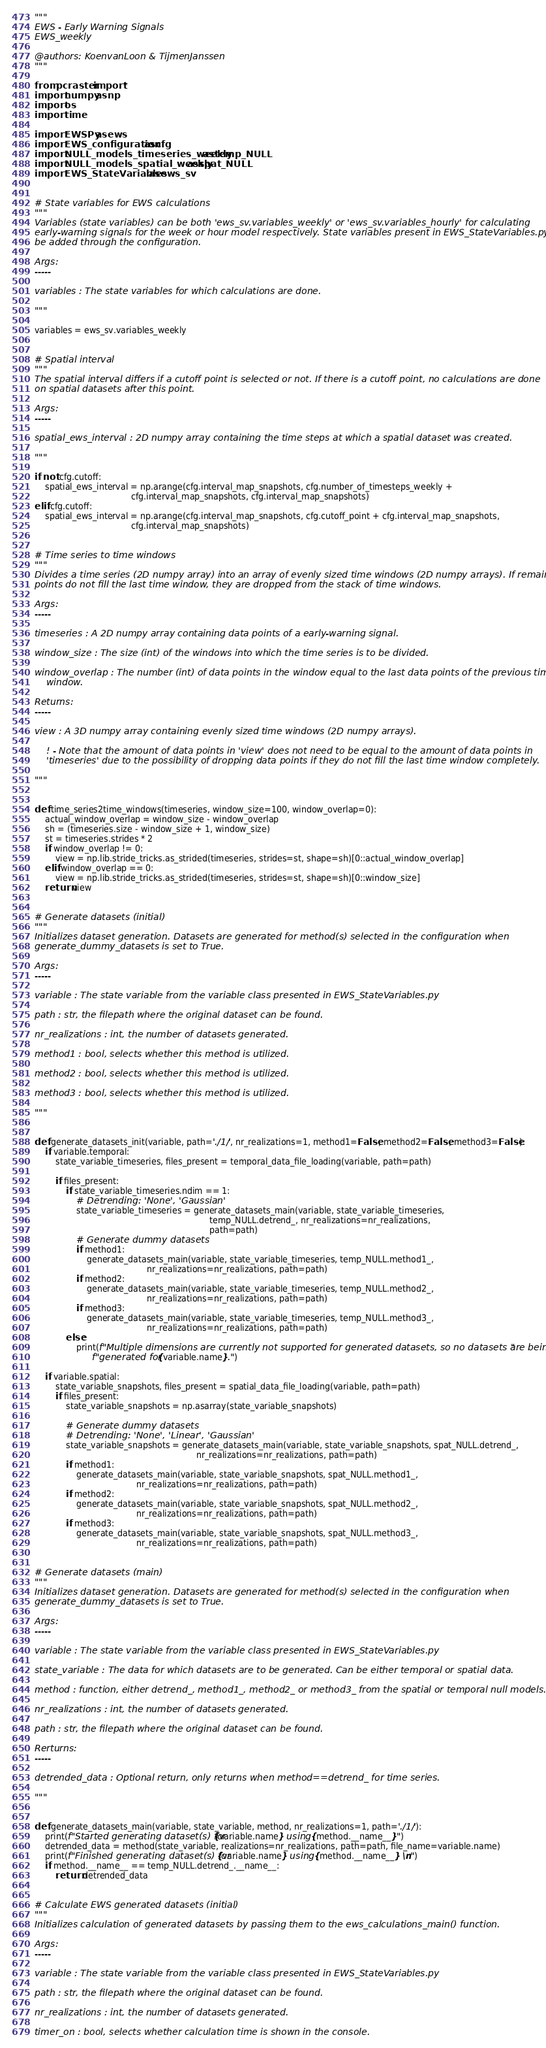<code> <loc_0><loc_0><loc_500><loc_500><_Python_>"""
EWS - Early Warning Signals
EWS_weekly

@authors: KoenvanLoon & TijmenJanssen
"""

from pcraster import *
import numpy as np
import os
import time

import EWSPy as ews
import EWS_configuration as cfg
import NULL_models_timeseries_weekly as temp_NULL
import NULL_models_spatial_weekly as spat_NULL
import EWS_StateVariables as ews_sv


# State variables for EWS calculations
"""
Variables (state variables) can be both 'ews_sv.variables_weekly' or 'ews_sv.variables_hourly' for calculating
early-warning signals for the week or hour model respectively. State variables present in EWS_StateVariables.py can
be added through the configuration.

Args:
-----

variables : The state variables for which calculations are done.

"""

variables = ews_sv.variables_weekly


# Spatial interval
"""
The spatial interval differs if a cutoff point is selected or not. If there is a cutoff point, no calculations are done
on spatial datasets after this point.

Args:
-----

spatial_ews_interval : 2D numpy array containing the time steps at which a spatial dataset was created.

"""

if not cfg.cutoff:
    spatial_ews_interval = np.arange(cfg.interval_map_snapshots, cfg.number_of_timesteps_weekly +
                                     cfg.interval_map_snapshots, cfg.interval_map_snapshots)
elif cfg.cutoff:
    spatial_ews_interval = np.arange(cfg.interval_map_snapshots, cfg.cutoff_point + cfg.interval_map_snapshots,
                                     cfg.interval_map_snapshots)


# Time series to time windows
"""
Divides a time series (2D numpy array) into an array of evenly sized time windows (2D numpy arrays). If remaining data-
points do not fill the last time window, they are dropped from the stack of time windows.

Args:
-----

timeseries : A 2D numpy array containing data points of a early-warning signal.

window_size : The size (int) of the windows into which the time series is to be divided.

window_overlap : The number (int) of data points in the window equal to the last data points of the previous time 
    window.

Returns:
-----

view : A 3D numpy array containing evenly sized time windows (2D numpy arrays).

    ! - Note that the amount of data points in 'view' does not need to be equal to the amount of data points in 
    'timeseries' due to the possibility of dropping data points if they do not fill the last time window completely.

"""


def time_series2time_windows(timeseries, window_size=100, window_overlap=0):
    actual_window_overlap = window_size - window_overlap
    sh = (timeseries.size - window_size + 1, window_size)
    st = timeseries.strides * 2
    if window_overlap != 0:
        view = np.lib.stride_tricks.as_strided(timeseries, strides=st, shape=sh)[0::actual_window_overlap]
    elif window_overlap == 0:
        view = np.lib.stride_tricks.as_strided(timeseries, strides=st, shape=sh)[0::window_size]
    return view


# Generate datasets (initial)
"""
Initializes dataset generation. Datasets are generated for method(s) selected in the configuration when 
generate_dummy_datasets is set to True. 

Args:
-----

variable : The state variable from the variable class presented in EWS_StateVariables.py 

path : str, the filepath where the original dataset can be found.

nr_realizations : int, the number of datasets generated.

method1 : bool, selects whether this method is utilized.

method2 : bool, selects whether this method is utilized.

method3 : bool, selects whether this method is utilized.

"""


def generate_datasets_init(variable, path='./1/', nr_realizations=1, method1=False, method2=False, method3=False):
    if variable.temporal:
        state_variable_timeseries, files_present = temporal_data_file_loading(variable, path=path)

        if files_present:
            if state_variable_timeseries.ndim == 1:
                # Detrending: 'None', 'Gaussian'
                state_variable_timeseries = generate_datasets_main(variable, state_variable_timeseries,
                                                                   temp_NULL.detrend_, nr_realizations=nr_realizations,
                                                                   path=path)
                # Generate dummy datasets
                if method1:
                    generate_datasets_main(variable, state_variable_timeseries, temp_NULL.method1_,
                                           nr_realizations=nr_realizations, path=path)
                if method2:
                    generate_datasets_main(variable, state_variable_timeseries, temp_NULL.method2_,
                                           nr_realizations=nr_realizations, path=path)
                if method3:
                    generate_datasets_main(variable, state_variable_timeseries, temp_NULL.method3_,
                                           nr_realizations=nr_realizations, path=path)
            else:
                print(f"Multiple dimensions are currently not supported for generated datasets, so no datasets are being "
                      f"generated for {variable.name}.")

    if variable.spatial:
        state_variable_snapshots, files_present = spatial_data_file_loading(variable, path=path)
        if files_present:
            state_variable_snapshots = np.asarray(state_variable_snapshots)

            # Generate dummy datasets
            # Detrending: 'None', 'Linear', 'Gaussian'
            state_variable_snapshots = generate_datasets_main(variable, state_variable_snapshots, spat_NULL.detrend_,
                                                              nr_realizations=nr_realizations, path=path)
            if method1:
                generate_datasets_main(variable, state_variable_snapshots, spat_NULL.method1_,
                                       nr_realizations=nr_realizations, path=path)
            if method2:
                generate_datasets_main(variable, state_variable_snapshots, spat_NULL.method2_,
                                       nr_realizations=nr_realizations, path=path)
            if method3:
                generate_datasets_main(variable, state_variable_snapshots, spat_NULL.method3_,
                                       nr_realizations=nr_realizations, path=path)


# Generate datasets (main)
"""
Initializes dataset generation. Datasets are generated for method(s) selected in the configuration when 
generate_dummy_datasets is set to True. 

Args:
-----

variable : The state variable from the variable class presented in EWS_StateVariables.py

state_variable : The data for which datasets are to be generated. Can be either temporal or spatial data.

method : function, either detrend_, method1_, method2_ or method3_ from the spatial or temporal null models.

nr_realizations : int, the number of datasets generated.

path : str, the filepath where the original dataset can be found.

Rerturns:
-----

detrended_data : Optional return, only returns when method==detrend_ for time series.

"""


def generate_datasets_main(variable, state_variable, method, nr_realizations=1, path='./1/'):
    print(f"Started generating dataset(s) for {variable.name} using {method.__name__}")
    detrended_data = method(state_variable, realizations=nr_realizations, path=path, file_name=variable.name)
    print(f"Finished generating dataset(s) for {variable.name} using {method.__name__} \n")
    if method.__name__ == temp_NULL.detrend_.__name__:
        return detrended_data


# Calculate EWS generated datasets (initial)
"""
Initializes calculation of generated datasets by passing them to the ews_calculations_main() function. 

Args:
-----

variable : The state variable from the variable class presented in EWS_StateVariables.py 

path : str, the filepath where the original dataset can be found.

nr_realizations : int, the number of datasets generated.

timer_on : bool, selects whether calculation time is shown in the console.
</code> 